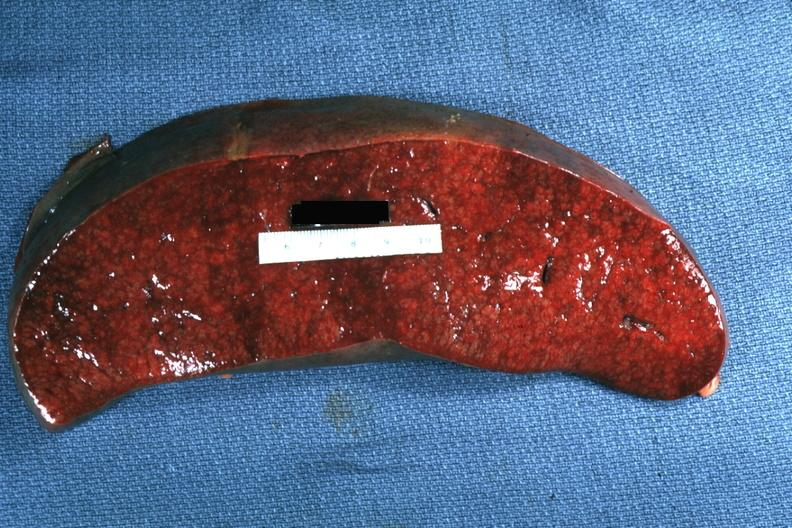does foot show cut surface with apparent infiltrative process case of chronic lymphocytic leukemia progressing to acute lymphocytic leukemia?
Answer the question using a single word or phrase. No 